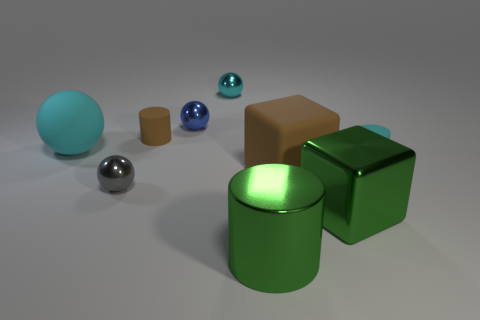Do the large shiny cube and the rubber cube have the same color?
Offer a very short reply. No. What is the color of the other large object that is the same shape as the gray shiny thing?
Offer a terse response. Cyan. Does the ball to the left of the small gray shiny sphere have the same color as the metal cylinder?
Your response must be concise. No. What is the shape of the matte thing that is the same color as the large matte ball?
Your answer should be very brief. Cylinder. How many big balls have the same material as the big cylinder?
Your response must be concise. 0. There is a tiny cyan ball; how many things are on the left side of it?
Your response must be concise. 4. The rubber cube has what size?
Keep it short and to the point. Large. What color is the metallic thing that is the same size as the green cylinder?
Offer a terse response. Green. Are there any small blocks of the same color as the metal cylinder?
Your answer should be very brief. No. What material is the blue ball?
Offer a terse response. Metal. 